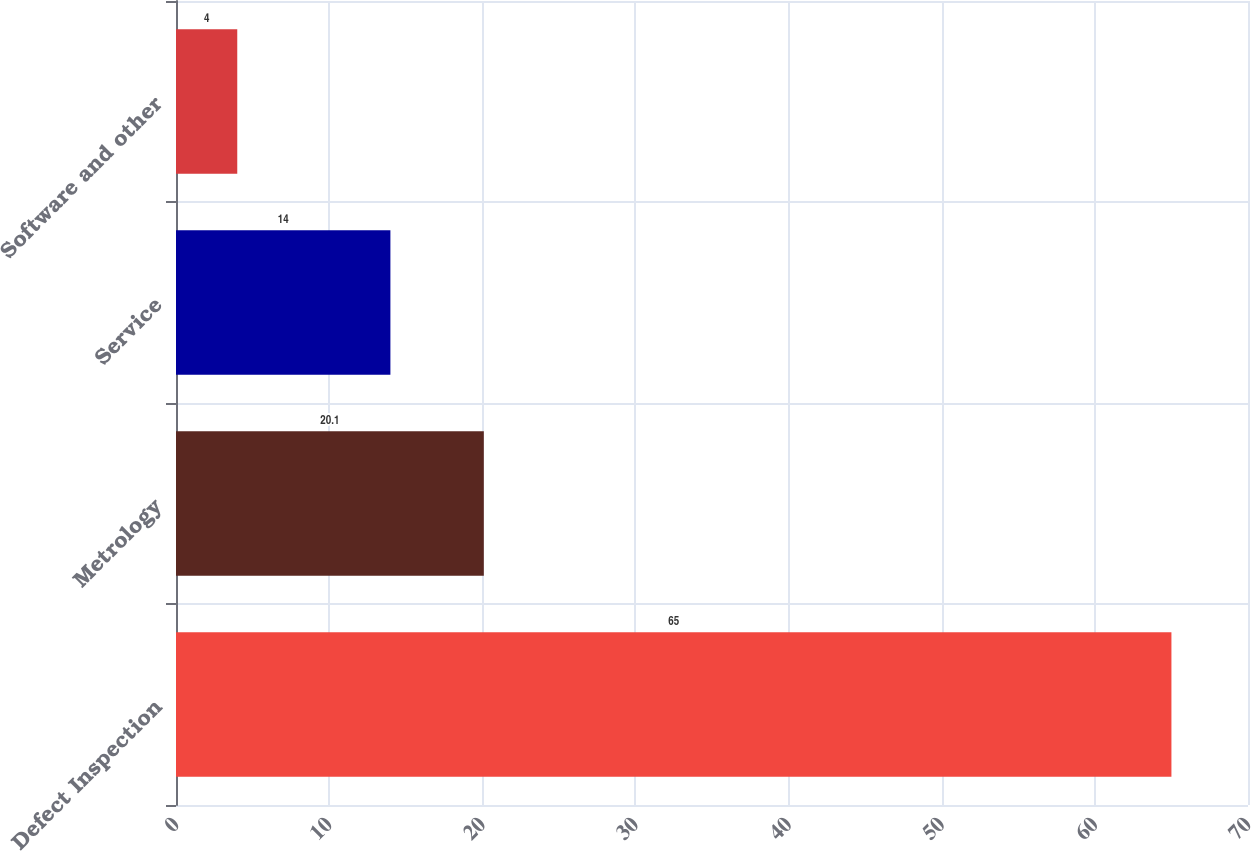Convert chart. <chart><loc_0><loc_0><loc_500><loc_500><bar_chart><fcel>Defect Inspection<fcel>Metrology<fcel>Service<fcel>Software and other<nl><fcel>65<fcel>20.1<fcel>14<fcel>4<nl></chart> 